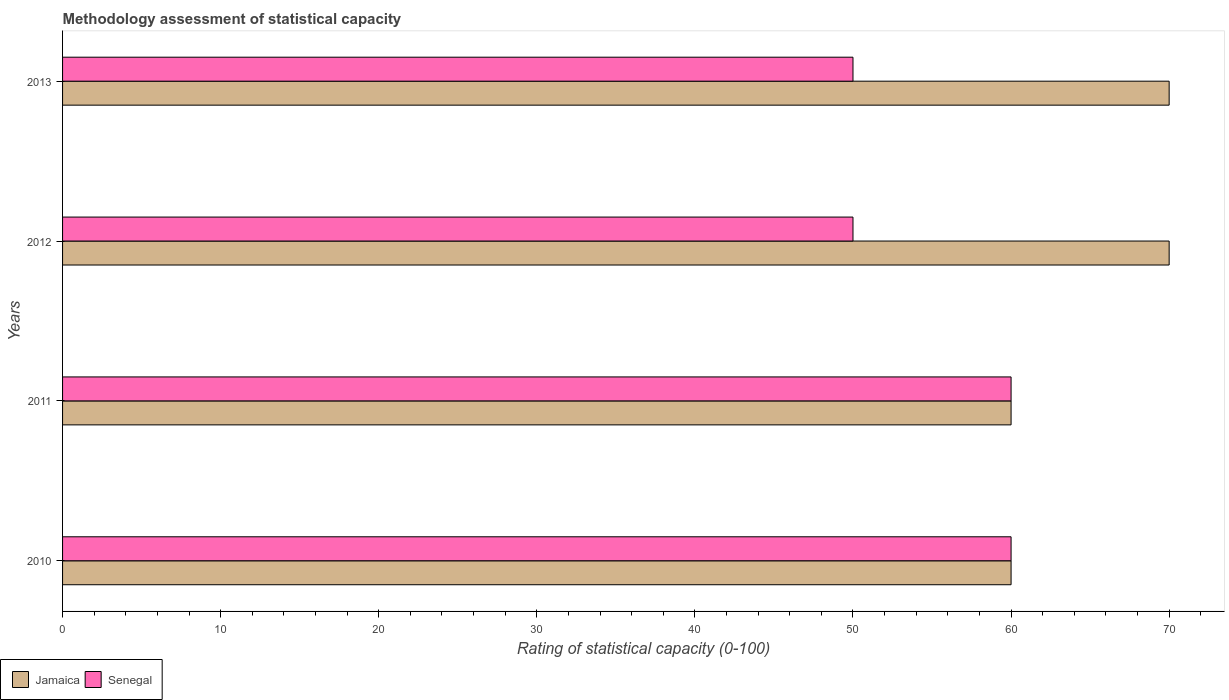How many groups of bars are there?
Give a very brief answer. 4. How many bars are there on the 1st tick from the top?
Provide a short and direct response. 2. What is the label of the 1st group of bars from the top?
Provide a succinct answer. 2013. In how many cases, is the number of bars for a given year not equal to the number of legend labels?
Your response must be concise. 0. What is the rating of statistical capacity in Senegal in 2010?
Give a very brief answer. 60. Across all years, what is the maximum rating of statistical capacity in Jamaica?
Make the answer very short. 70. Across all years, what is the minimum rating of statistical capacity in Jamaica?
Your response must be concise. 60. In which year was the rating of statistical capacity in Senegal maximum?
Your answer should be very brief. 2010. What is the total rating of statistical capacity in Senegal in the graph?
Give a very brief answer. 220. What is the difference between the rating of statistical capacity in Senegal in 2012 and that in 2013?
Your response must be concise. 0. What is the difference between the rating of statistical capacity in Jamaica in 2010 and the rating of statistical capacity in Senegal in 2013?
Your answer should be compact. 10. What is the average rating of statistical capacity in Jamaica per year?
Keep it short and to the point. 65. In the year 2013, what is the difference between the rating of statistical capacity in Senegal and rating of statistical capacity in Jamaica?
Provide a short and direct response. -20. Is the rating of statistical capacity in Senegal in 2010 less than that in 2011?
Offer a terse response. No. Is the difference between the rating of statistical capacity in Senegal in 2012 and 2013 greater than the difference between the rating of statistical capacity in Jamaica in 2012 and 2013?
Your answer should be compact. No. What is the difference between the highest and the second highest rating of statistical capacity in Senegal?
Make the answer very short. 0. What is the difference between the highest and the lowest rating of statistical capacity in Jamaica?
Keep it short and to the point. 10. In how many years, is the rating of statistical capacity in Senegal greater than the average rating of statistical capacity in Senegal taken over all years?
Keep it short and to the point. 2. Is the sum of the rating of statistical capacity in Jamaica in 2010 and 2013 greater than the maximum rating of statistical capacity in Senegal across all years?
Your answer should be very brief. Yes. What does the 2nd bar from the top in 2012 represents?
Your response must be concise. Jamaica. What does the 1st bar from the bottom in 2013 represents?
Your answer should be very brief. Jamaica. How many bars are there?
Give a very brief answer. 8. Does the graph contain grids?
Provide a succinct answer. No. How are the legend labels stacked?
Provide a short and direct response. Horizontal. What is the title of the graph?
Keep it short and to the point. Methodology assessment of statistical capacity. Does "Heavily indebted poor countries" appear as one of the legend labels in the graph?
Provide a short and direct response. No. What is the label or title of the X-axis?
Offer a very short reply. Rating of statistical capacity (0-100). What is the label or title of the Y-axis?
Offer a very short reply. Years. What is the Rating of statistical capacity (0-100) of Senegal in 2010?
Offer a terse response. 60. What is the Rating of statistical capacity (0-100) of Jamaica in 2012?
Offer a terse response. 70. What is the Rating of statistical capacity (0-100) in Senegal in 2012?
Offer a terse response. 50. What is the Rating of statistical capacity (0-100) of Jamaica in 2013?
Your response must be concise. 70. What is the Rating of statistical capacity (0-100) in Senegal in 2013?
Offer a terse response. 50. Across all years, what is the minimum Rating of statistical capacity (0-100) of Jamaica?
Your answer should be very brief. 60. What is the total Rating of statistical capacity (0-100) of Jamaica in the graph?
Your response must be concise. 260. What is the total Rating of statistical capacity (0-100) of Senegal in the graph?
Give a very brief answer. 220. What is the difference between the Rating of statistical capacity (0-100) of Jamaica in 2010 and that in 2012?
Provide a succinct answer. -10. What is the difference between the Rating of statistical capacity (0-100) in Jamaica in 2010 and that in 2013?
Ensure brevity in your answer.  -10. What is the difference between the Rating of statistical capacity (0-100) of Senegal in 2010 and that in 2013?
Keep it short and to the point. 10. What is the difference between the Rating of statistical capacity (0-100) in Jamaica in 2011 and that in 2012?
Give a very brief answer. -10. What is the difference between the Rating of statistical capacity (0-100) of Jamaica in 2011 and that in 2013?
Your answer should be very brief. -10. What is the difference between the Rating of statistical capacity (0-100) of Senegal in 2011 and that in 2013?
Give a very brief answer. 10. What is the difference between the Rating of statistical capacity (0-100) in Jamaica in 2010 and the Rating of statistical capacity (0-100) in Senegal in 2012?
Give a very brief answer. 10. What is the difference between the Rating of statistical capacity (0-100) of Jamaica in 2011 and the Rating of statistical capacity (0-100) of Senegal in 2012?
Your answer should be compact. 10. What is the average Rating of statistical capacity (0-100) of Jamaica per year?
Offer a terse response. 65. In the year 2010, what is the difference between the Rating of statistical capacity (0-100) in Jamaica and Rating of statistical capacity (0-100) in Senegal?
Provide a succinct answer. 0. In the year 2011, what is the difference between the Rating of statistical capacity (0-100) in Jamaica and Rating of statistical capacity (0-100) in Senegal?
Your response must be concise. 0. In the year 2013, what is the difference between the Rating of statistical capacity (0-100) in Jamaica and Rating of statistical capacity (0-100) in Senegal?
Offer a very short reply. 20. What is the ratio of the Rating of statistical capacity (0-100) in Senegal in 2010 to that in 2011?
Offer a terse response. 1. What is the ratio of the Rating of statistical capacity (0-100) of Jamaica in 2010 to that in 2012?
Offer a very short reply. 0.86. What is the ratio of the Rating of statistical capacity (0-100) in Senegal in 2010 to that in 2013?
Provide a succinct answer. 1.2. What is the ratio of the Rating of statistical capacity (0-100) in Senegal in 2011 to that in 2012?
Provide a short and direct response. 1.2. What is the ratio of the Rating of statistical capacity (0-100) in Jamaica in 2011 to that in 2013?
Your response must be concise. 0.86. What is the ratio of the Rating of statistical capacity (0-100) in Senegal in 2012 to that in 2013?
Offer a terse response. 1. What is the difference between the highest and the lowest Rating of statistical capacity (0-100) in Jamaica?
Make the answer very short. 10. 